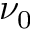<formula> <loc_0><loc_0><loc_500><loc_500>\nu _ { 0 }</formula> 